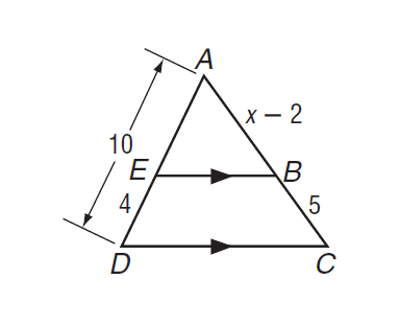Question: If E B \parallel D C, find x.
Choices:
A. 2
B. 4
C. 5
D. 9.5
Answer with the letter. Answer: D 